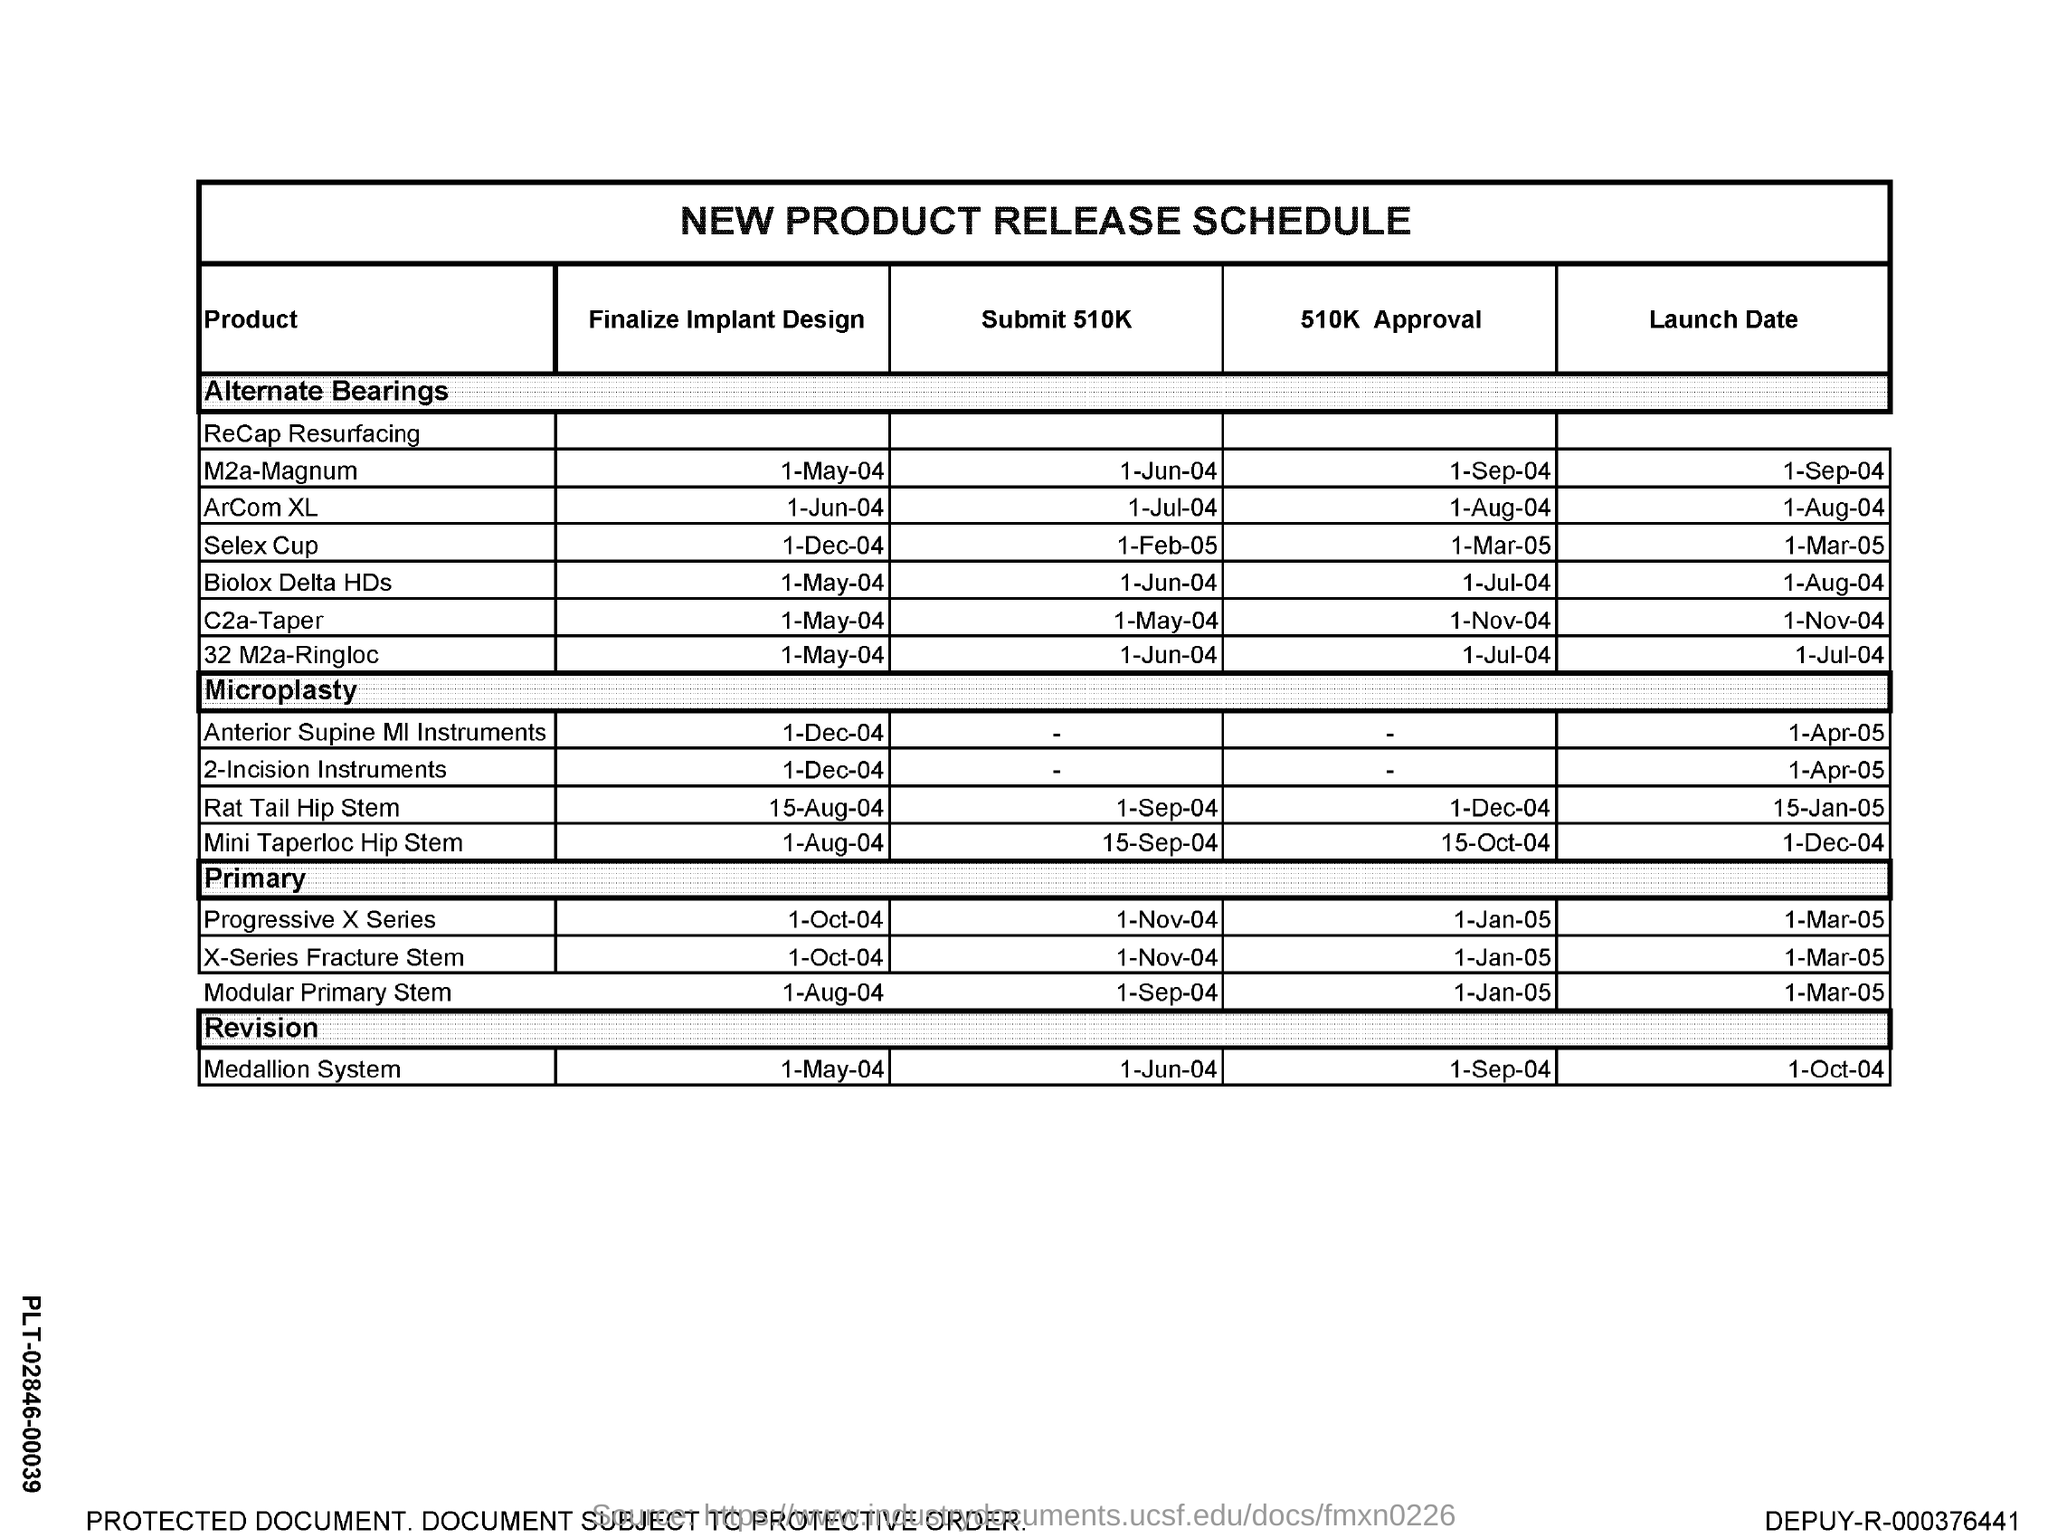Give some essential details in this illustration. The finalize Implant design of C2a-Taper is scheduled for 1-MAY-04. The finalize implant design of 32 M2a-Ringloc is scheduled for 1-MAY-04. The Submit 510K of Selex Cup is scheduled for 1 February 2005. The Submit 510K of M2a-Magnum is scheduled for 1 June 2004. The finalize design of the ArCom XL implant is scheduled for June 1st, 2004. 